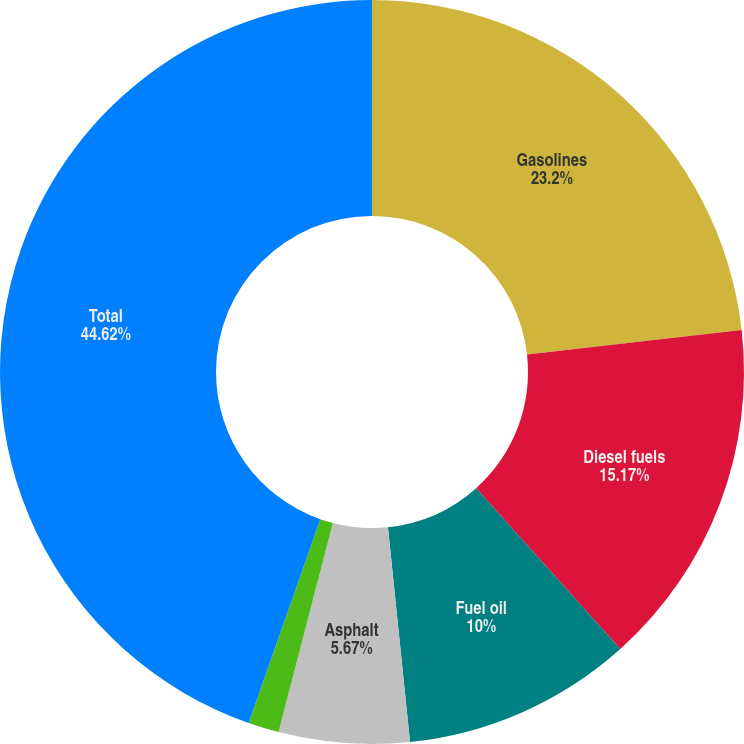Convert chart to OTSL. <chart><loc_0><loc_0><loc_500><loc_500><pie_chart><fcel>Gasolines<fcel>Diesel fuels<fcel>Fuel oil<fcel>Asphalt<fcel>LPG and other<fcel>Total<nl><fcel>23.2%<fcel>15.17%<fcel>10.0%<fcel>5.67%<fcel>1.34%<fcel>44.62%<nl></chart> 